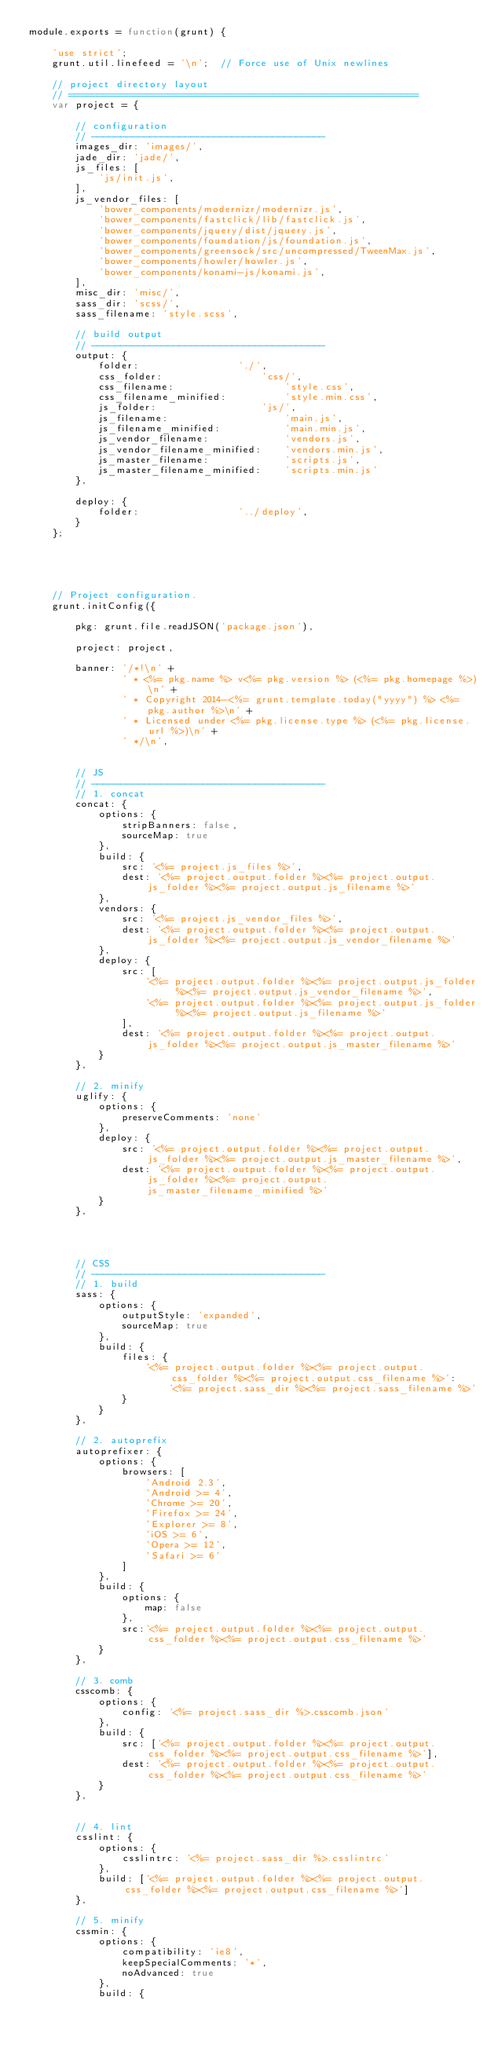Convert code to text. <code><loc_0><loc_0><loc_500><loc_500><_JavaScript_>module.exports = function(grunt) {

    'use strict';
    grunt.util.linefeed = '\n';  // Force use of Unix newlines

    // project directory layout
    // ============================================================
    var project = {

        // configuration
        // ----------------------------------------
        images_dir: 'images/',
        jade_dir: 'jade/',
        js_files: [
            'js/init.js',
        ],
        js_vendor_files: [
            'bower_components/modernizr/modernizr.js',
            'bower_components/fastclick/lib/fastclick.js',
            'bower_components/jquery/dist/jquery.js',
            'bower_components/foundation/js/foundation.js',
            'bower_components/greensock/src/uncompressed/TweenMax.js',
            'bower_components/howler/howler.js',
            'bower_components/konami-js/konami.js',
        ],
        misc_dir: 'misc/',
        sass_dir: 'scss/',
        sass_filename: 'style.scss',

        // build output
        // ----------------------------------------
        output: {
            folder:                 './',
            css_folder:                 'css/',
            css_filename:                   'style.css',
            css_filename_minified:          'style.min.css',
            js_folder:                  'js/',
            js_filename:                    'main.js',
            js_filename_minified:           'main.min.js',
            js_vendor_filename:             'vendors.js',
            js_vendor_filename_minified:    'vendors.min.js',
            js_master_filename:             'scripts.js',
            js_master_filename_minified:    'scripts.min.js'
        },

        deploy: {
            folder:                 '../deploy',
        }
    };





    // Project configuration.
    grunt.initConfig({

        pkg: grunt.file.readJSON('package.json'),

        project: project,

        banner: '/*!\n' +
                ' * <%= pkg.name %> v<%= pkg.version %> (<%= pkg.homepage %>)\n' +
                ' * Copyright 2014-<%= grunt.template.today("yyyy") %> <%= pkg.author %>\n' +
                ' * Licensed under <%= pkg.license.type %> (<%= pkg.license.url %>)\n' +
                ' */\n',


        // JS
        // ----------------------------------------
        // 1. concat
        concat: {
            options: {
                stripBanners: false,
                sourceMap: true
            },
            build: {
                src: '<%= project.js_files %>',
                dest: '<%= project.output.folder %><%= project.output.js_folder %><%= project.output.js_filename %>'
            },
            vendors: {
                src: '<%= project.js_vendor_files %>',
                dest: '<%= project.output.folder %><%= project.output.js_folder %><%= project.output.js_vendor_filename %>'
            },
            deploy: {
                src: [
                    '<%= project.output.folder %><%= project.output.js_folder %><%= project.output.js_vendor_filename %>',
                    '<%= project.output.folder %><%= project.output.js_folder %><%= project.output.js_filename %>'
                ],
                dest: '<%= project.output.folder %><%= project.output.js_folder %><%= project.output.js_master_filename %>'
            }
        },

        // 2. minify
        uglify: {
            options: {
                preserveComments: 'none'
            },
            deploy: {
                src: '<%= project.output.folder %><%= project.output.js_folder %><%= project.output.js_master_filename %>',
                dest: '<%= project.output.folder %><%= project.output.js_folder %><%= project.output.js_master_filename_minified %>'
            }
        },




        // CSS
        // ----------------------------------------
        // 1. build
        sass: {
            options: {
                outputStyle: 'expanded',
                sourceMap: true
            },
            build: {
                files: {
                    '<%= project.output.folder %><%= project.output.css_folder %><%= project.output.css_filename %>':
                        '<%= project.sass_dir %><%= project.sass_filename %>'
                }
            }
        },

        // 2. autoprefix
        autoprefixer: {
            options: {
                browsers: [
                    'Android 2.3',
                    'Android >= 4',
                    'Chrome >= 20',
                    'Firefox >= 24',
                    'Explorer >= 8',
                    'iOS >= 6',
                    'Opera >= 12',
                    'Safari >= 6'
                ]
            },
            build: {
                options: {
                    map: false
                },
                src:'<%= project.output.folder %><%= project.output.css_folder %><%= project.output.css_filename %>'
            }
        },

        // 3. comb
        csscomb: {
            options: {
                config: '<%= project.sass_dir %>.csscomb.json'
            },
            build: {
                src: ['<%= project.output.folder %><%= project.output.css_folder %><%= project.output.css_filename %>'],
                dest: '<%= project.output.folder %><%= project.output.css_folder %><%= project.output.css_filename %>'
            }
        },


        // 4. lint
        csslint: {
            options: {
                csslintrc: '<%= project.sass_dir %>.csslintrc'
            },
            build: ['<%= project.output.folder %><%= project.output.css_folder %><%= project.output.css_filename %>']
        },

        // 5. minify
        cssmin: {
            options: {
                compatibility: 'ie8',
                keepSpecialComments: '*',
                noAdvanced: true
            },
            build: {</code> 